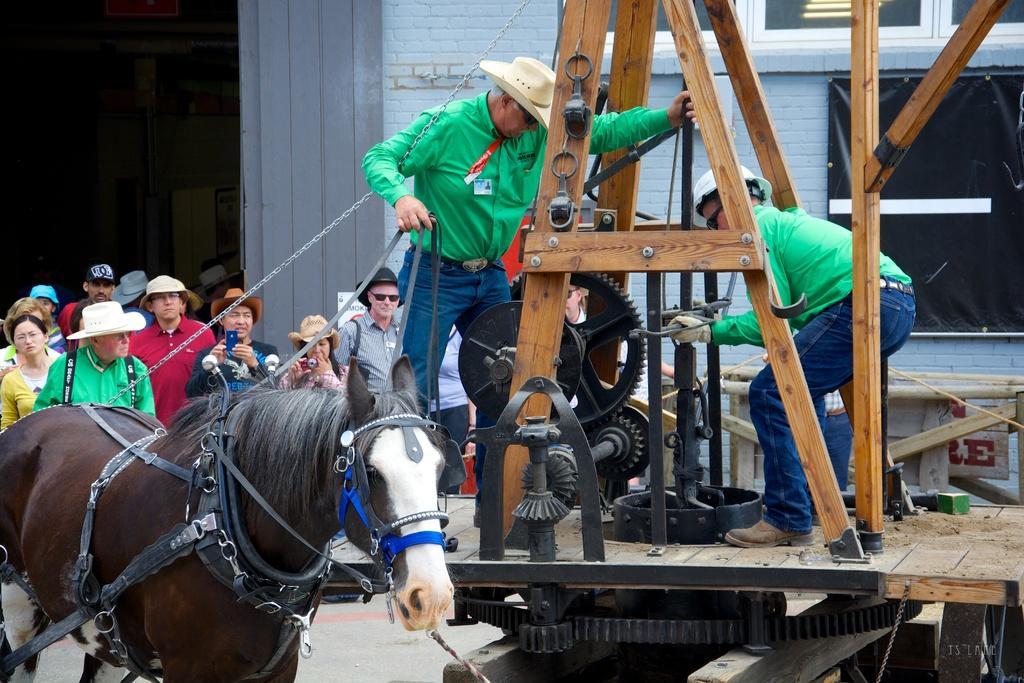Can you describe this image briefly? In this image there is a horse, on the right side there is a machine, on that there are two persons standing, in the background there are people standing and there is a building. 